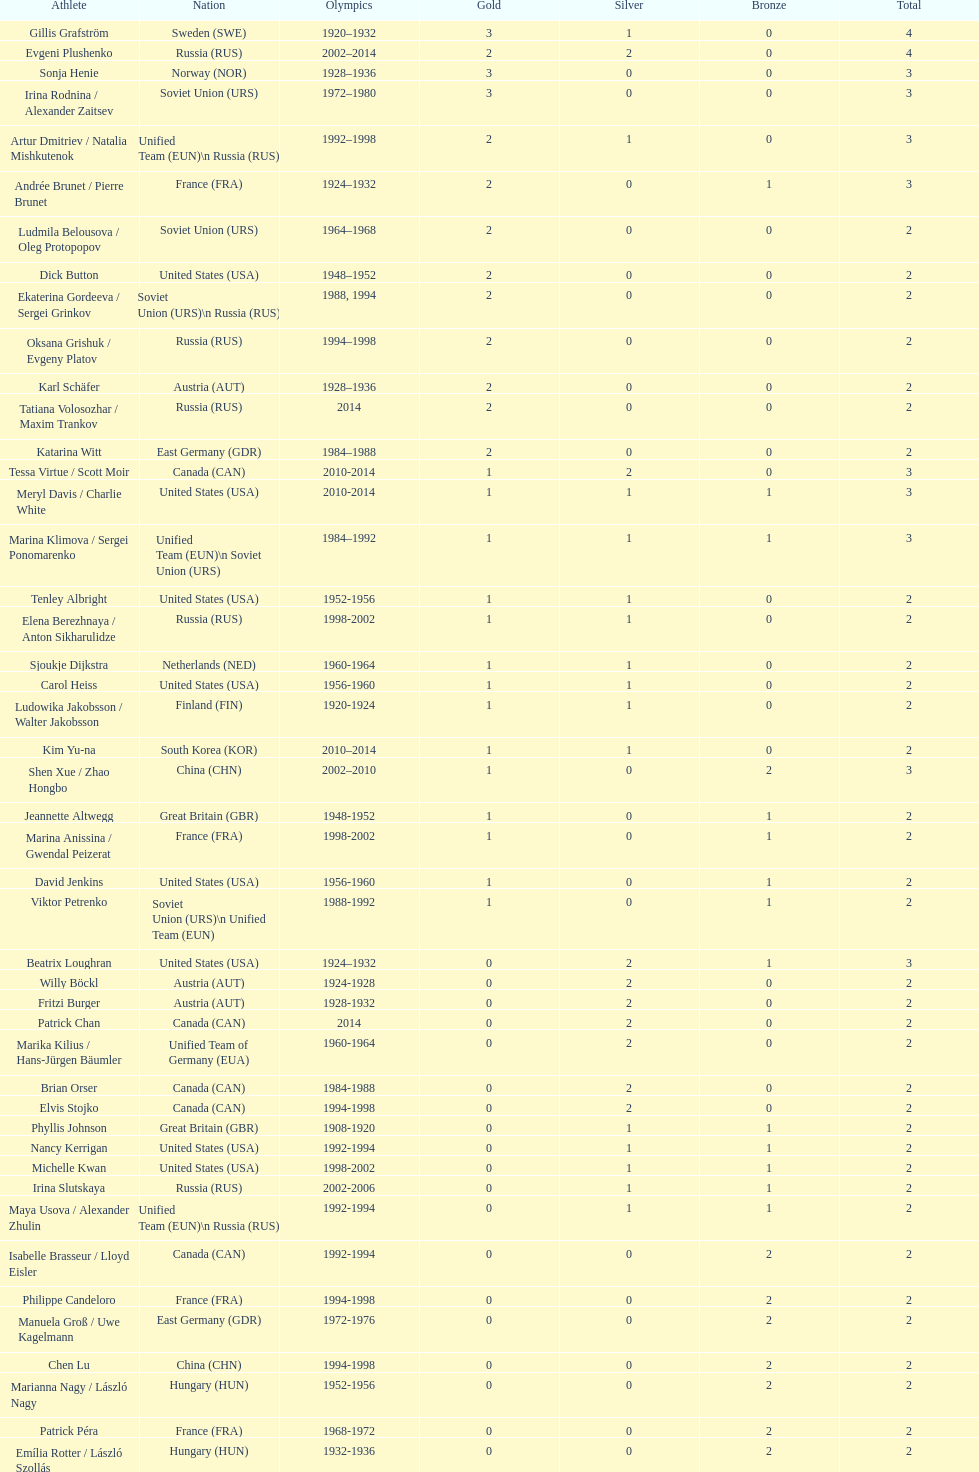What is the total number of medals won by sweden and norway together? 7. 